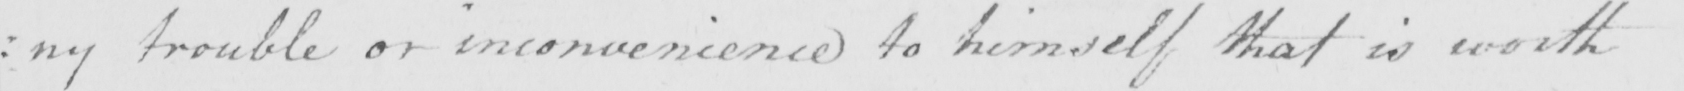Please provide the text content of this handwritten line. trouble or inconvenience to himself that is worth 